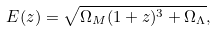<formula> <loc_0><loc_0><loc_500><loc_500>E ( z ) = \sqrt { \Omega _ { M } ( 1 + z ) ^ { 3 } + \Omega _ { \Lambda } } ,</formula> 